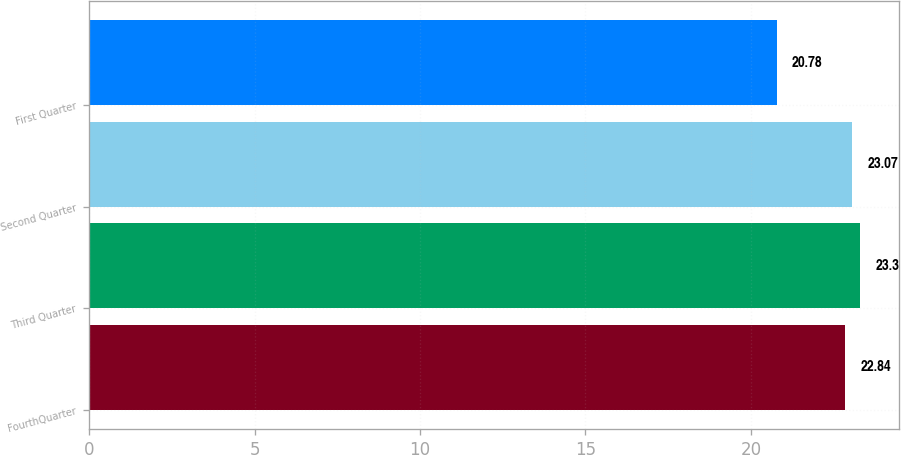Convert chart. <chart><loc_0><loc_0><loc_500><loc_500><bar_chart><fcel>FourthQuarter<fcel>Third Quarter<fcel>Second Quarter<fcel>First Quarter<nl><fcel>22.84<fcel>23.3<fcel>23.07<fcel>20.78<nl></chart> 